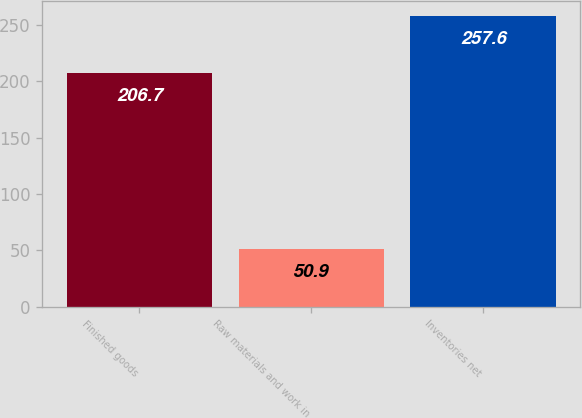<chart> <loc_0><loc_0><loc_500><loc_500><bar_chart><fcel>Finished goods<fcel>Raw materials and work in<fcel>Inventories net<nl><fcel>206.7<fcel>50.9<fcel>257.6<nl></chart> 